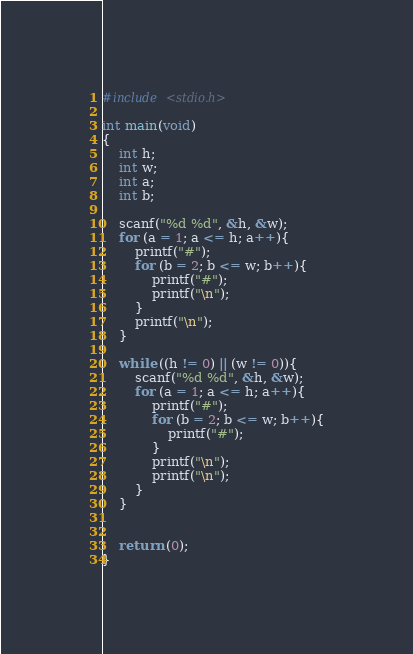Convert code to text. <code><loc_0><loc_0><loc_500><loc_500><_C_>#include <stdio.h>

int main(void)
{
	int h;
	int w;
	int a;
	int b;
	
	scanf("%d %d", &h, &w);
	for (a = 1; a <= h; a++){
		printf("#");
		for (b = 2; b <= w; b++){
			printf("#");
			printf("\n");
		}
		printf("\n");
	}
	
	while ((h != 0) || (w != 0)){
		scanf("%d %d", &h, &w);
		for (a = 1; a <= h; a++){
			printf("#");
			for (b = 2; b <= w; b++){
				printf("#");
			}
			printf("\n");
			printf("\n");
		}
	}
	
	
	return (0);
}</code> 